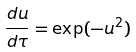Convert formula to latex. <formula><loc_0><loc_0><loc_500><loc_500>\frac { d u } { d \tau } = \exp ( - u ^ { 2 } )</formula> 